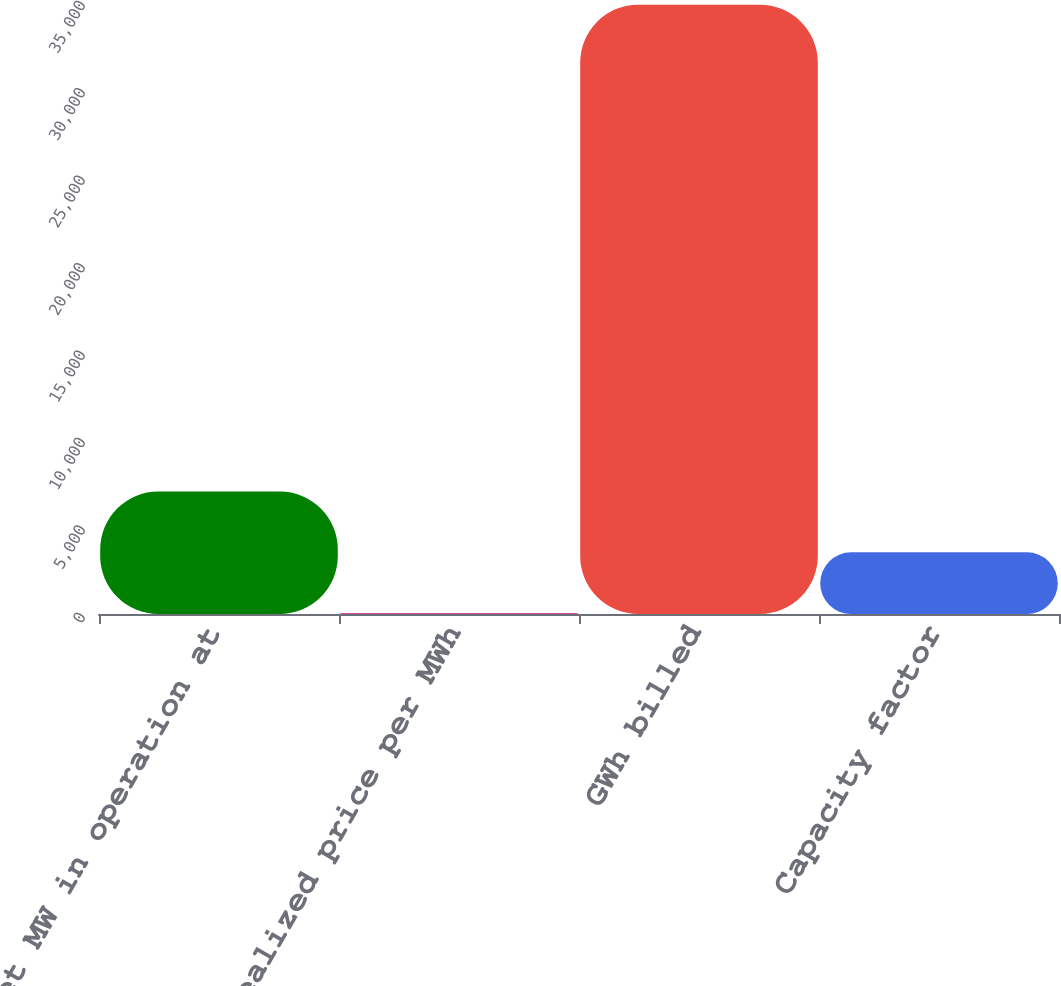Convert chart. <chart><loc_0><loc_0><loc_500><loc_500><bar_chart><fcel>Net MW in operation at<fcel>Average realized price per MWh<fcel>GWh billed<fcel>Capacity factor<nl><fcel>7004.87<fcel>44.33<fcel>34847<fcel>3524.6<nl></chart> 